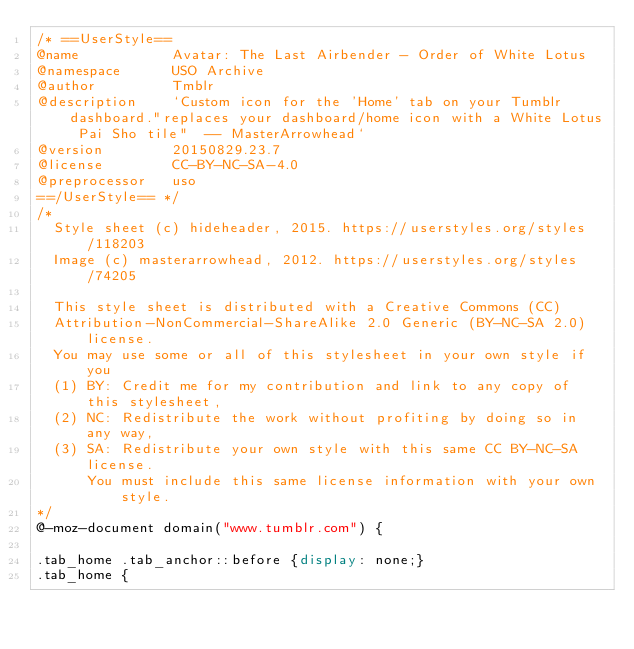Convert code to text. <code><loc_0><loc_0><loc_500><loc_500><_CSS_>/* ==UserStyle==
@name           Avatar: The Last Airbender - Order of White Lotus
@namespace      USO Archive
@author         Tmblr
@description    `Custom icon for the 'Home' tab on your Tumblr dashboard."replaces your dashboard/home icon with a White Lotus Pai Sho tile"  -- MasterArrowhead`
@version        20150829.23.7
@license        CC-BY-NC-SA-4.0
@preprocessor   uso
==/UserStyle== */
/*
  Style sheet (c) hideheader, 2015. https://userstyles.org/styles/118203
  Image (c) masterarrowhead, 2012. https://userstyles.org/styles/74205

  This style sheet is distributed with a Creative Commons (CC)
  Attribution-NonCommercial-ShareAlike 2.0 Generic (BY-NC-SA 2.0) license.
  You may use some or all of this stylesheet in your own style if you
  (1) BY: Credit me for my contribution and link to any copy of this stylesheet,
  (2) NC: Redistribute the work without profiting by doing so in any way,
  (3) SA: Redistribute your own style with this same CC BY-NC-SA license.
      You must include this same license information with your own style.
*/
@-moz-document domain("www.tumblr.com") {

.tab_home .tab_anchor::before {display: none;}
.tab_home {</code> 